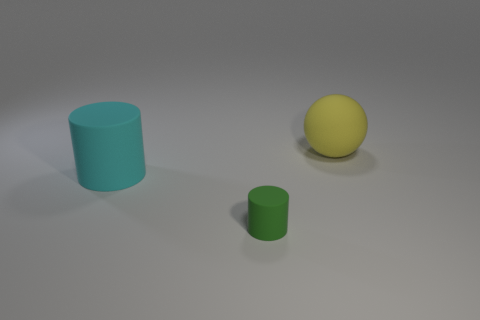Add 1 large purple spheres. How many objects exist? 4 Subtract all balls. How many objects are left? 2 Subtract all tiny brown shiny cubes. Subtract all green matte cylinders. How many objects are left? 2 Add 3 tiny rubber objects. How many tiny rubber objects are left? 4 Add 2 large green metal objects. How many large green metal objects exist? 2 Subtract 0 blue blocks. How many objects are left? 3 